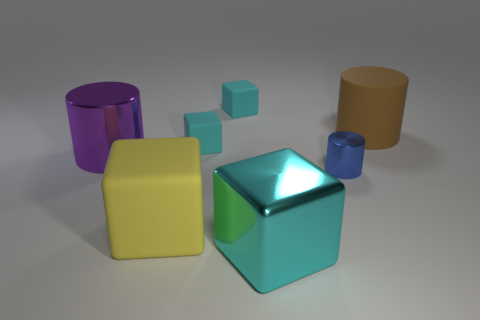There is a large metal thing that is on the right side of the large purple metallic thing; is its color the same as the tiny matte cube that is in front of the big brown matte cylinder?
Keep it short and to the point. Yes. Is there another metal object of the same shape as the small metal object?
Your answer should be compact. Yes. The cyan metallic object that is the same size as the yellow object is what shape?
Give a very brief answer. Cube. Are there the same number of rubber cylinders in front of the big brown matte thing and big brown matte cylinders left of the large yellow object?
Keep it short and to the point. Yes. What size is the metal thing that is in front of the rubber cube in front of the blue cylinder?
Keep it short and to the point. Large. Are there any yellow balls that have the same size as the yellow block?
Your response must be concise. No. What color is the cube that is the same material as the blue object?
Provide a succinct answer. Cyan. Is the number of green rubber cylinders less than the number of blue cylinders?
Make the answer very short. Yes. There is a big thing that is behind the cyan shiny thing and in front of the large metal cylinder; what material is it?
Ensure brevity in your answer.  Rubber. There is a cyan block that is in front of the small blue cylinder; is there a tiny metallic cylinder that is behind it?
Your response must be concise. Yes. 